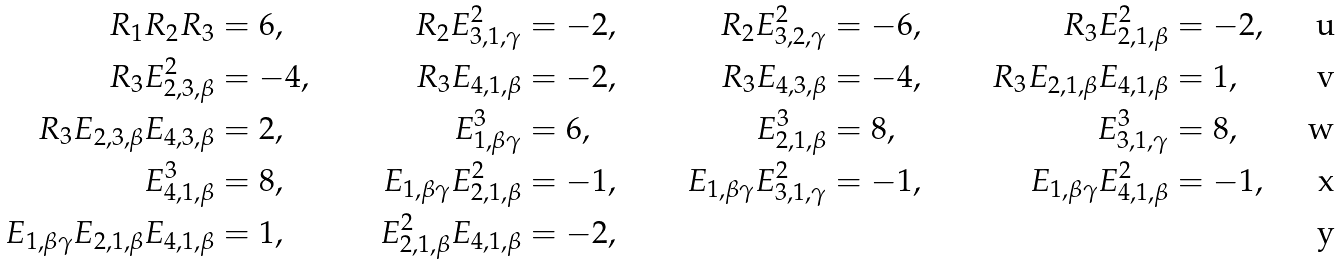Convert formula to latex. <formula><loc_0><loc_0><loc_500><loc_500>R _ { 1 } R _ { 2 } R _ { 3 } & = 6 , & R _ { 2 } E _ { 3 , 1 , \gamma } ^ { 2 } & = - 2 , & R _ { 2 } E _ { 3 , 2 , \gamma } ^ { 2 } & = - 6 , & R _ { 3 } E _ { 2 , 1 , \beta } ^ { 2 } & = - 2 , \\ R _ { 3 } E _ { 2 , 3 , \beta } ^ { 2 } & = - 4 , & R _ { 3 } E _ { 4 , 1 , \beta } & = - 2 , & R _ { 3 } E _ { 4 , 3 , \beta } & = - 4 , & R _ { 3 } E _ { 2 , 1 , \beta } E _ { 4 , 1 , \beta } & = 1 , \\ R _ { 3 } E _ { 2 , 3 , \beta } E _ { 4 , 3 , \beta } & = 2 , & E _ { 1 , \beta \gamma } ^ { 3 } & = 6 , & E _ { 2 , 1 , \beta } ^ { 3 } & = 8 , & E _ { 3 , 1 , \gamma } ^ { 3 } & = 8 , \\ E _ { 4 , 1 , \beta } ^ { 3 } & = 8 , & E _ { 1 , \beta \gamma } E _ { 2 , 1 , \beta } ^ { 2 } & = - 1 , & E _ { 1 , \beta \gamma } E _ { 3 , 1 , \gamma } ^ { 2 } & = - 1 , & E _ { 1 , \beta \gamma } E _ { 4 , 1 , \beta } ^ { 2 } & = - 1 , \\ E _ { 1 , \beta \gamma } E _ { 2 , 1 , \beta } E _ { 4 , 1 , \beta } & = 1 , & E _ { 2 , 1 , \beta } ^ { 2 } E _ { 4 , 1 , \beta } & = - 2 ,</formula> 